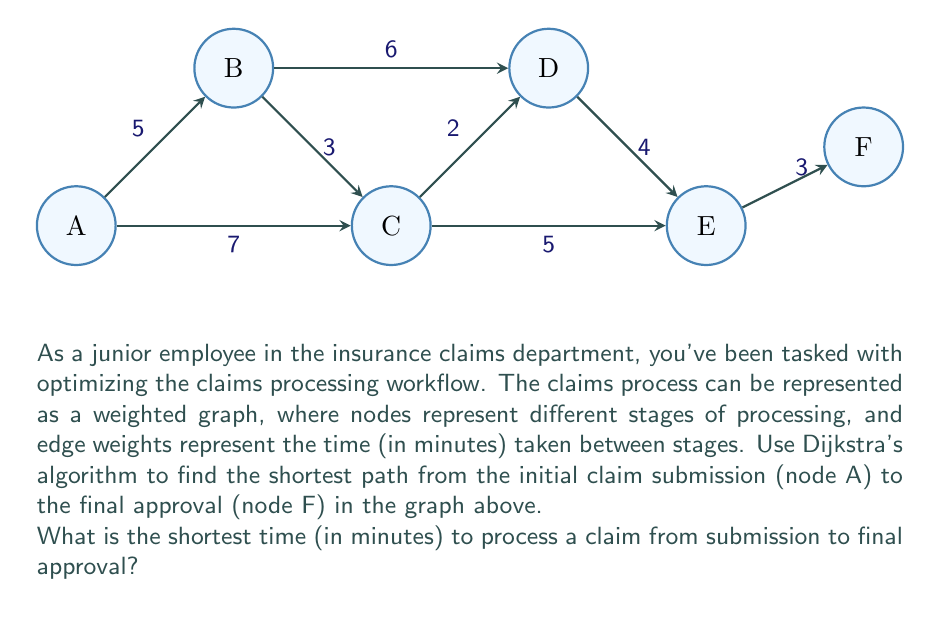Can you answer this question? Let's apply Dijkstra's algorithm to find the shortest path from node A to node F:

1) Initialize:
   - Set distance to A as 0, all others as infinity.
   - Set all nodes as unvisited.
   - Set A as the current node.

2) For the current node, consider all unvisited neighbors and calculate their tentative distances:
   - A to B: 0 + 5 = 5
   - A to C: 0 + 7 = 7
   Update the neighbor distances if smaller than the current recorded distance.

3) Mark A as visited. Set B as the current node (smallest tentative distance).

4) From B:
   - B to C: 5 + 3 = 8 (larger than current 7, no update)
   - B to D: 5 + 6 = 11

5) Mark B as visited. Set C as the current node.

6) From C:
   - C to D: 7 + 2 = 9 (update D from 11 to 9)
   - C to E: 7 + 5 = 12

7) Mark C as visited. Set D as the current node.

8) From D:
   - D to E: 9 + 4 = 13 (update E from 12 to 13)

9) Mark D as visited. Set E as the current node.

10) From E:
    - E to F: 13 + 3 = 16

11) Mark E as visited. F is the only unvisited node left.

The shortest path is A → C → D → E → F, with a total time of 16 minutes.
Answer: 16 minutes 